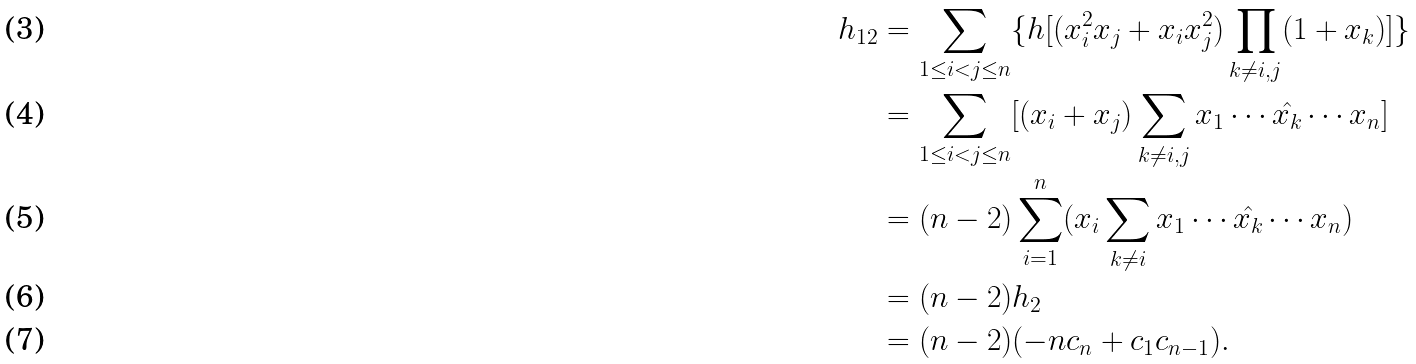<formula> <loc_0><loc_0><loc_500><loc_500>h _ { 1 2 } & = \sum _ { 1 \leq i < j \leq n } \{ h [ ( x _ { i } ^ { 2 } x _ { j } + x _ { i } x _ { j } ^ { 2 } ) \prod _ { k \neq i , j } ( 1 + x _ { k } ) ] \} \\ & = \sum _ { 1 \leq i < j \leq n } [ ( x _ { i } + x _ { j } ) \sum _ { k \neq i , j } x _ { 1 } \cdots \hat { x _ { k } } \cdots x _ { n } ] \\ & = ( n - 2 ) \sum _ { i = 1 } ^ { n } ( x _ { i } \sum _ { k \neq i } x _ { 1 } \cdots \hat { x _ { k } } \cdots x _ { n } ) \\ & = ( n - 2 ) h _ { 2 } \\ & = ( n - 2 ) ( - n c _ { n } + c _ { 1 } c _ { n - 1 } ) .</formula> 